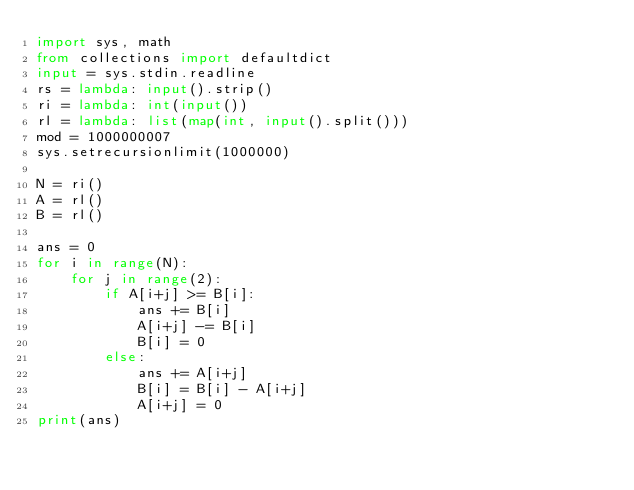Convert code to text. <code><loc_0><loc_0><loc_500><loc_500><_Python_>import sys, math
from collections import defaultdict
input = sys.stdin.readline
rs = lambda: input().strip()
ri = lambda: int(input())
rl = lambda: list(map(int, input().split()))
mod = 1000000007
sys.setrecursionlimit(1000000)

N = ri()
A = rl()
B = rl()

ans = 0
for i in range(N):
	for j in range(2):
		if A[i+j] >= B[i]:
			ans += B[i]
			A[i+j] -= B[i]
			B[i] = 0
		else:
			ans += A[i+j]
			B[i] = B[i] - A[i+j]
			A[i+j] = 0
print(ans)
</code> 